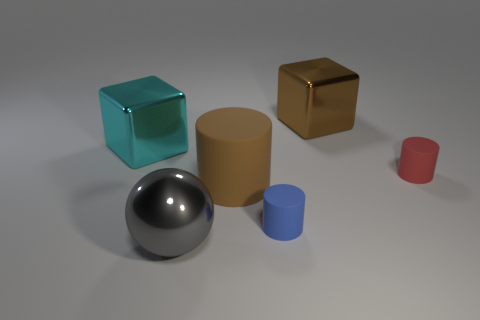Are any tiny brown rubber cubes visible?
Ensure brevity in your answer.  No. What material is the other object that is the same shape as the big cyan shiny thing?
Make the answer very short. Metal. Are there any gray metal spheres to the right of the brown metallic object?
Make the answer very short. No. Are the big cube that is on the right side of the cyan cube and the big ball made of the same material?
Ensure brevity in your answer.  Yes. Is there a large object that has the same color as the large cylinder?
Provide a succinct answer. Yes. What is the shape of the gray metallic object?
Provide a short and direct response. Sphere. There is a shiny block that is on the right side of the tiny object left of the small red cylinder; what is its color?
Offer a very short reply. Brown. How big is the rubber cylinder in front of the big brown rubber cylinder?
Provide a succinct answer. Small. Is there a large brown cylinder made of the same material as the big gray ball?
Your answer should be compact. No. How many other matte things have the same shape as the large rubber object?
Provide a succinct answer. 2. 